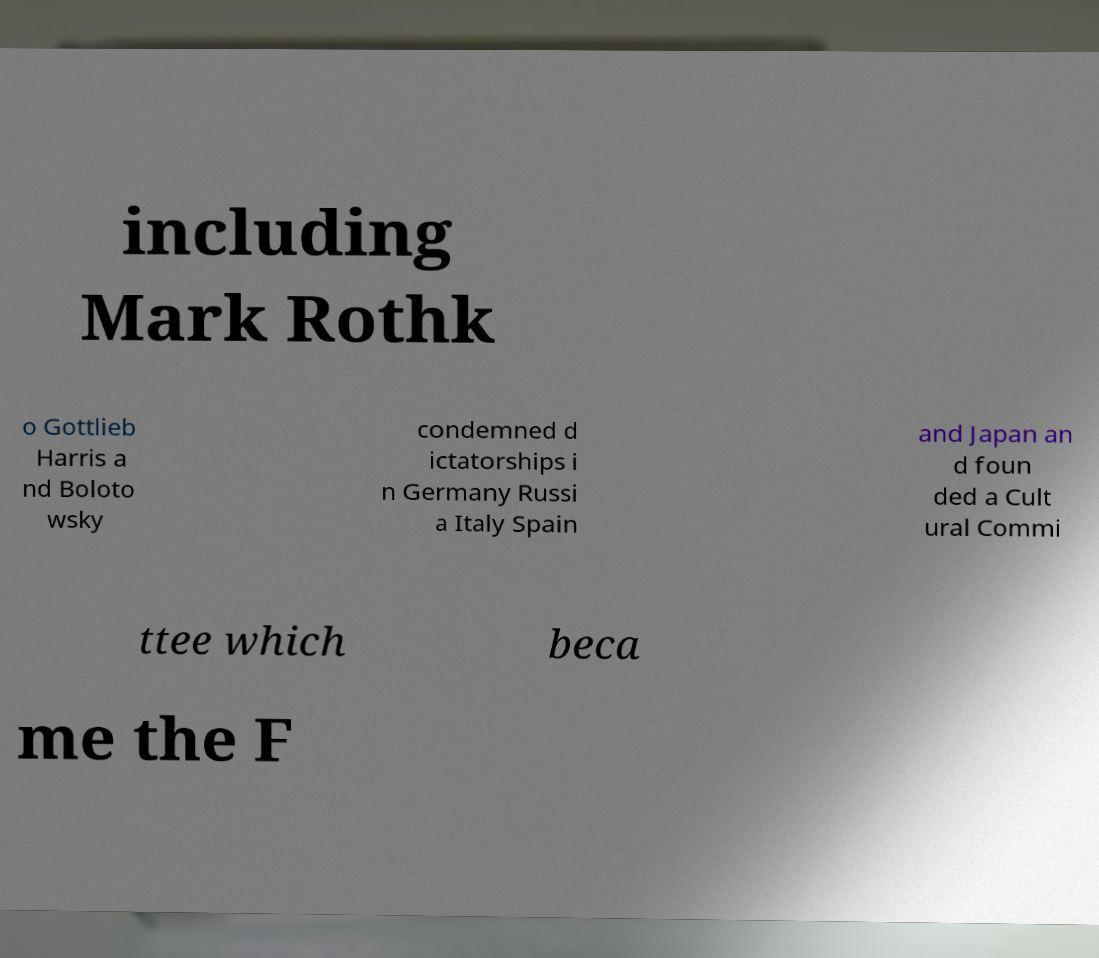Please identify and transcribe the text found in this image. including Mark Rothk o Gottlieb Harris a nd Boloto wsky condemned d ictatorships i n Germany Russi a Italy Spain and Japan an d foun ded a Cult ural Commi ttee which beca me the F 